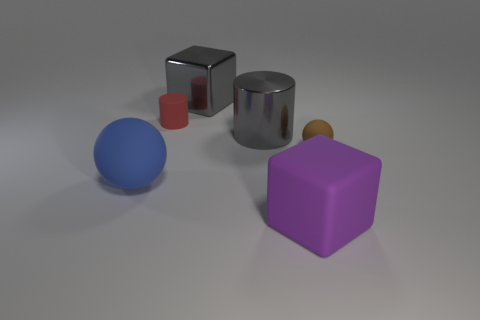Add 1 shiny objects. How many objects exist? 7 Subtract 1 cylinders. How many cylinders are left? 1 Subtract all balls. How many objects are left? 4 Add 6 large metal objects. How many large metal objects exist? 8 Subtract 0 purple spheres. How many objects are left? 6 Subtract all cyan blocks. Subtract all purple cylinders. How many blocks are left? 2 Subtract all large brown metallic cylinders. Subtract all brown things. How many objects are left? 5 Add 3 large shiny objects. How many large shiny objects are left? 5 